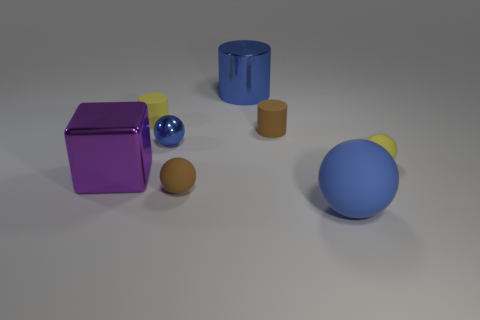Add 2 small purple matte cylinders. How many objects exist? 10 Subtract all cyan spheres. Subtract all purple cylinders. How many spheres are left? 4 Subtract all blocks. How many objects are left? 7 Subtract 1 blue cylinders. How many objects are left? 7 Subtract all blue shiny things. Subtract all large objects. How many objects are left? 3 Add 4 large blue balls. How many large blue balls are left? 5 Add 4 small red metallic objects. How many small red metallic objects exist? 4 